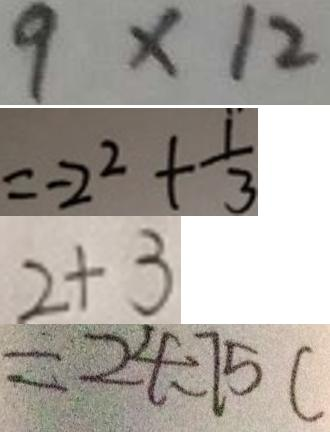<formula> <loc_0><loc_0><loc_500><loc_500>9 \times 1 2 
 = - 2 ^ { 2 } + \frac { 1 } { 3 } 
 2 + 3 
 = 2 4 - 7 5 c</formula> 